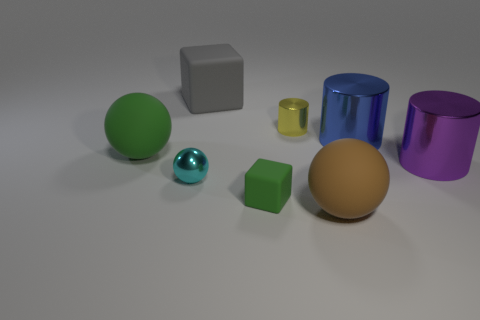Does the small green object have the same shape as the big gray thing?
Your answer should be very brief. Yes. The green rubber object that is the same shape as the gray matte object is what size?
Your answer should be very brief. Small. Do the blue metallic thing and the yellow cylinder have the same size?
Provide a succinct answer. No. There is a small metallic object behind the big metallic cylinder that is behind the green thing that is left of the small sphere; what is its shape?
Provide a short and direct response. Cylinder. What is the color of the big thing that is the same shape as the tiny rubber thing?
Provide a succinct answer. Gray. How big is the rubber thing that is on the right side of the cyan metal ball and behind the purple shiny thing?
Your answer should be compact. Large. How many rubber spheres are to the left of the large matte ball to the right of the rubber cube that is in front of the big gray matte thing?
Keep it short and to the point. 1. How many tiny objects are blue balls or blue cylinders?
Make the answer very short. 0. Is the material of the big object behind the yellow cylinder the same as the big green object?
Ensure brevity in your answer.  Yes. What is the material of the cube that is behind the big cylinder behind the matte ball that is behind the brown thing?
Offer a terse response. Rubber. 